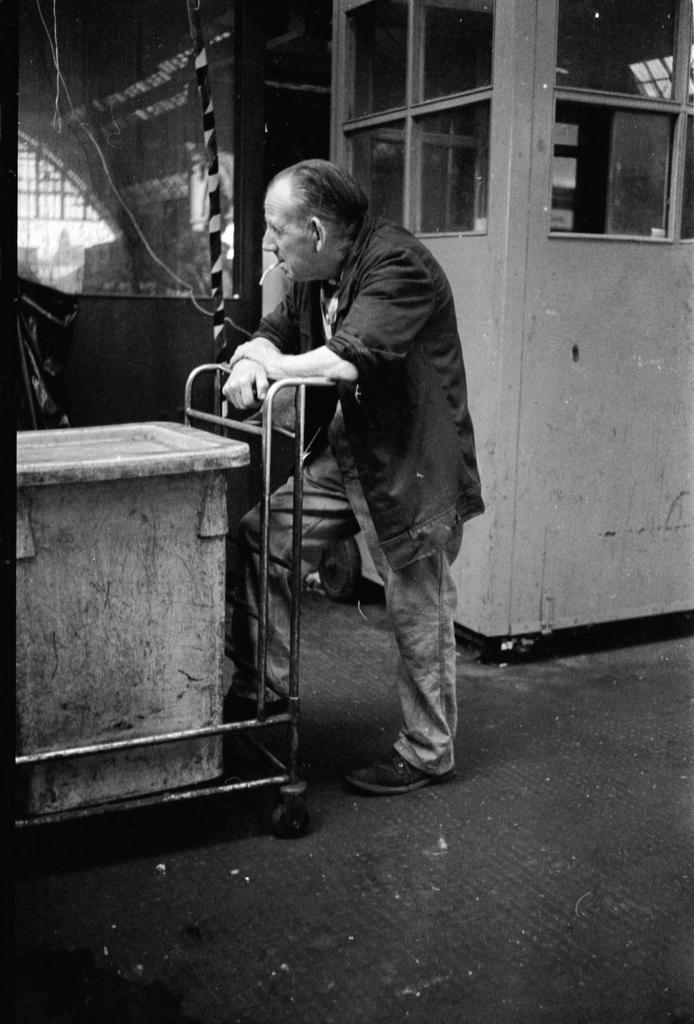What is the color scheme of the image? The image is black and white. What is the main subject of the image? There is a person in the middle of the image. What is the person doing in the image? The person has a cigarette in their mouth. What type of mine is visible in the background of the image? There is no mine visible in the image; it is a black and white image of a person with a cigarette in their mouth. What type of secretary can be seen working in the image? There is no secretary present in the image; it features a person with a cigarette in their mouth. 